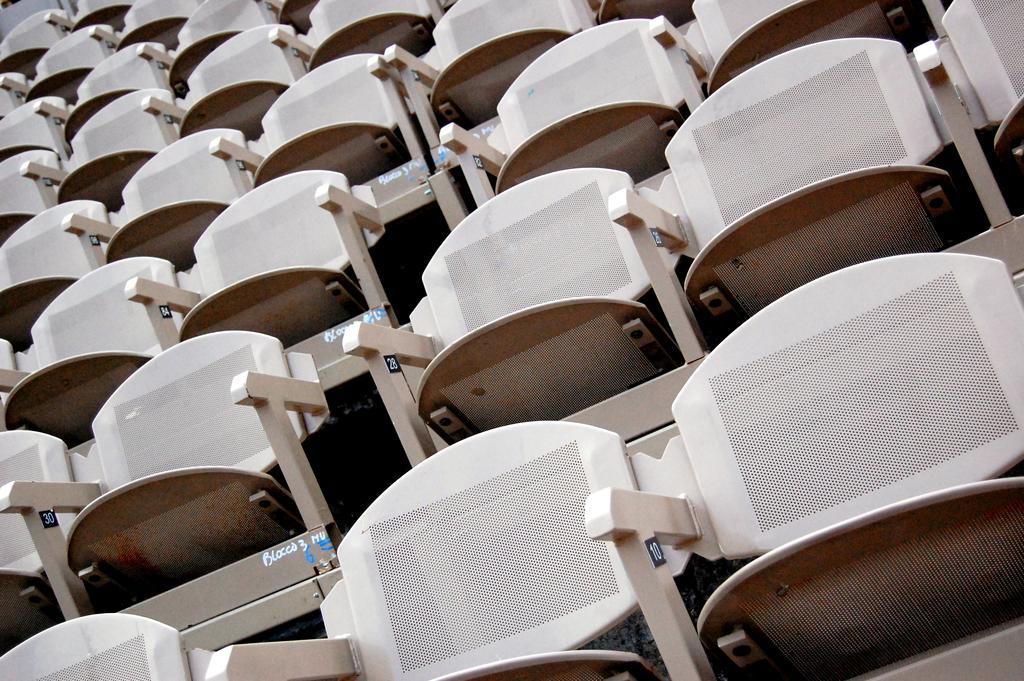Describe this image in one or two sentences. In the foreground of this image, there are chairs. 